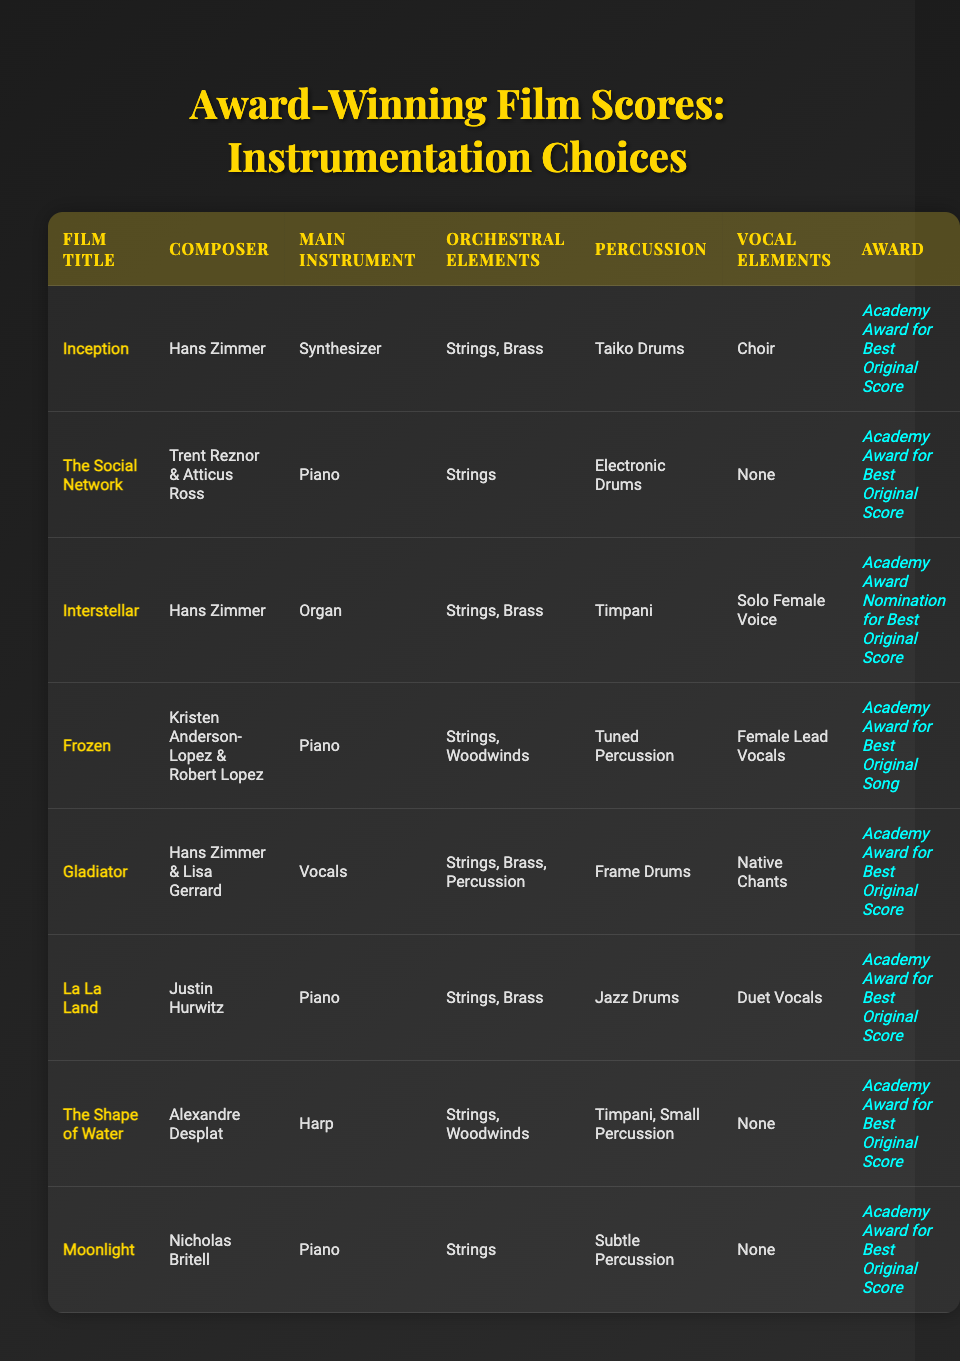What is the main instrument used in "Inception"? The table states that the main instrument for "Inception" is a synthesizer.
Answer: Synthesizer Which film won an Academy Award for Best Original Song? The table lists "Frozen" as the film that won an Academy Award for Best Original Song.
Answer: Frozen How many scores in the table primarily feature the piano as the main instrument? By checking the table, the films "The Social Network," "Frozen," "La La Land," and "Moonlight" all list piano as their main instrument, totaling four scores.
Answer: 4 Is there any score in the table that has vocal elements described as "None"? Both "The Social Network," "The Shape of Water," and "Moonlight" have vocal elements categorized as "None," making this statement true.
Answer: Yes Which composer created the score for "Gladiator"? The composer credited for "Gladiator" in the table is Hans Zimmer & Lisa Gerrard.
Answer: Hans Zimmer & Lisa Gerrard Which score features the highest number of different orchestral elements? The score for "Gladiator" displays a range of orchestral elements: strings, brass, and percussion, more than any other score listed.
Answer: Gladiator Which composer has the most entries in this table? Hans Zimmer is featured for "Inception," "Interstellar," and "Gladiator," totaling three entries, the highest number in the table.
Answer: Hans Zimmer Which film uses the harp as the main instrument? Referring to the table, "The Shape of Water" is identified as the film that uses the harp as the main instrument.
Answer: The Shape of Water What common percussion instrument is used in "Interstellar" and "Gladiator"? Both scores utilize timpani, as noted in the percussion columns for each film in the table.
Answer: Timpani 